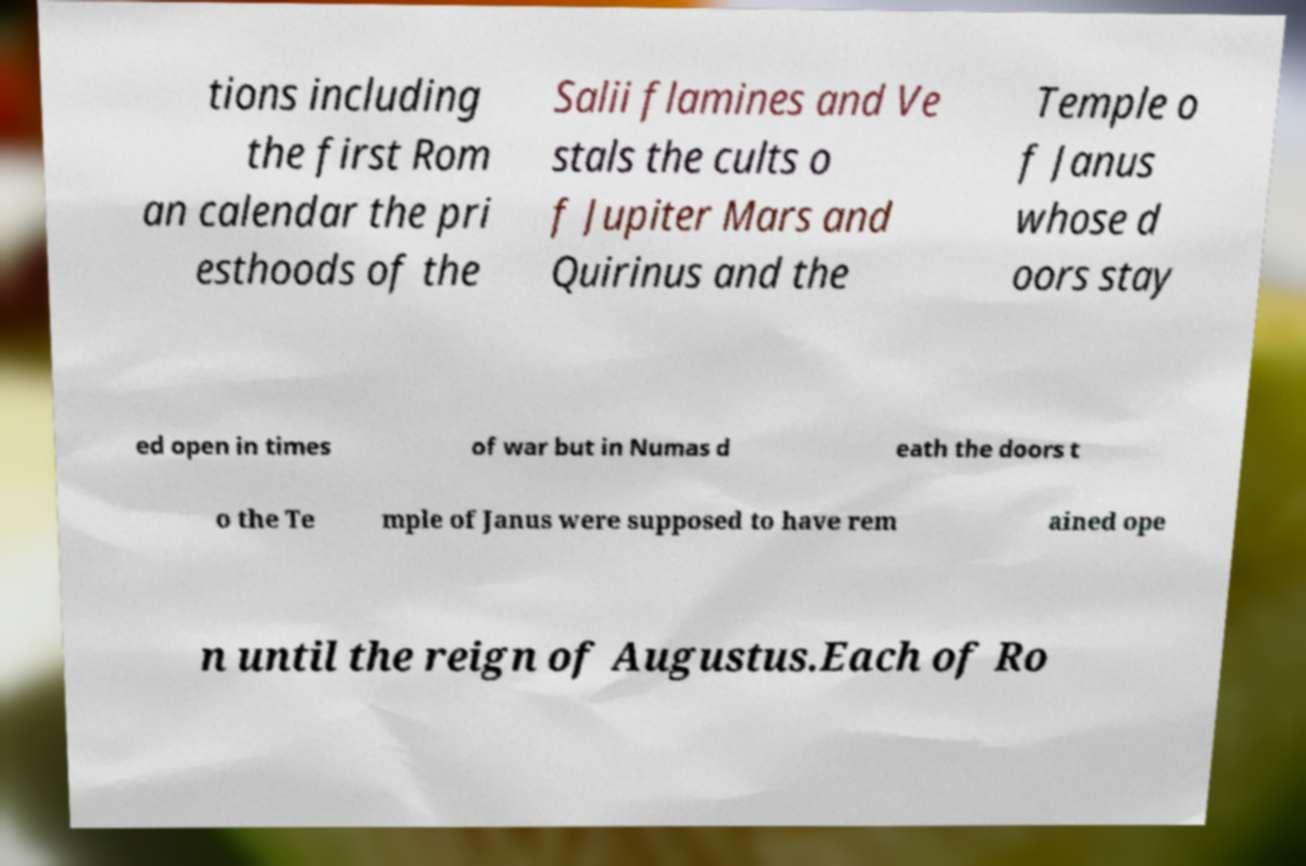Please read and relay the text visible in this image. What does it say? tions including the first Rom an calendar the pri esthoods of the Salii flamines and Ve stals the cults o f Jupiter Mars and Quirinus and the Temple o f Janus whose d oors stay ed open in times of war but in Numas d eath the doors t o the Te mple of Janus were supposed to have rem ained ope n until the reign of Augustus.Each of Ro 